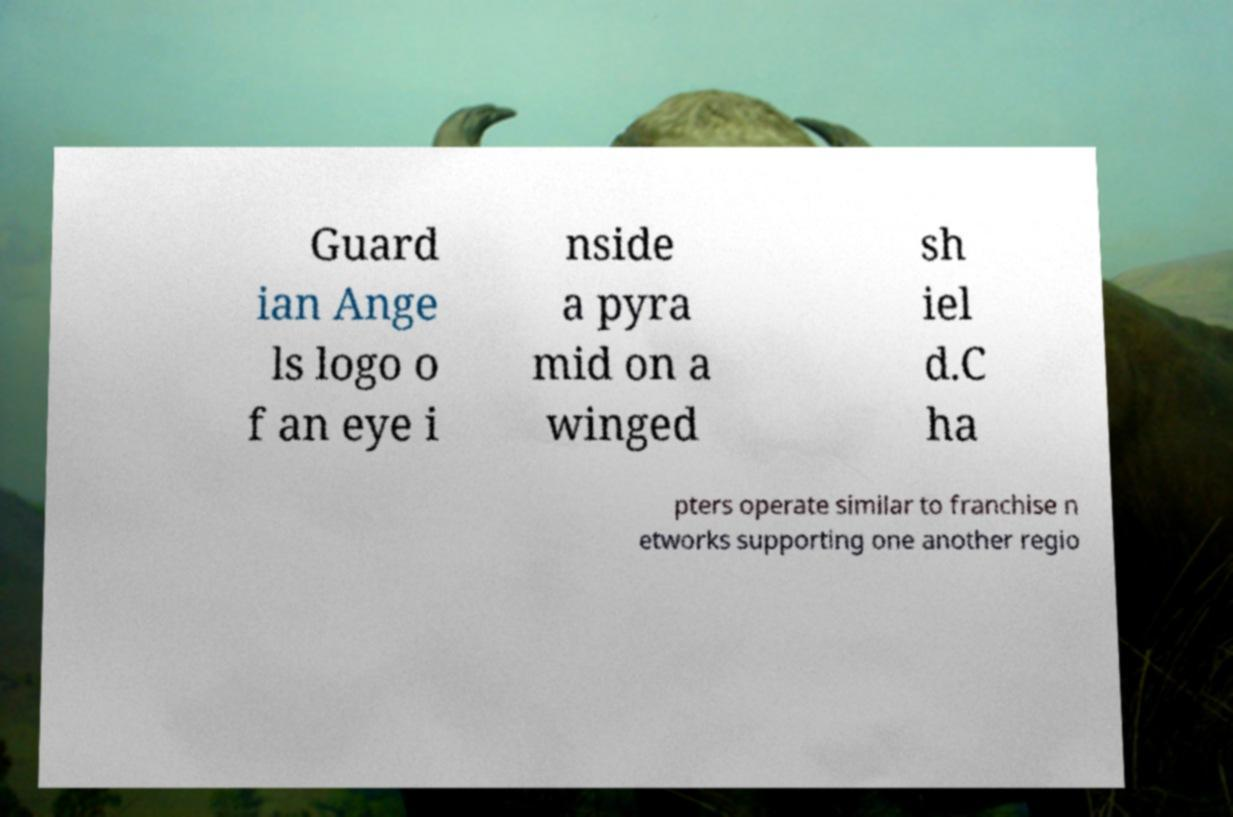For documentation purposes, I need the text within this image transcribed. Could you provide that? Guard ian Ange ls logo o f an eye i nside a pyra mid on a winged sh iel d.C ha pters operate similar to franchise n etworks supporting one another regio 